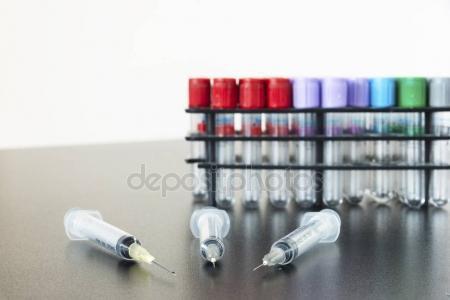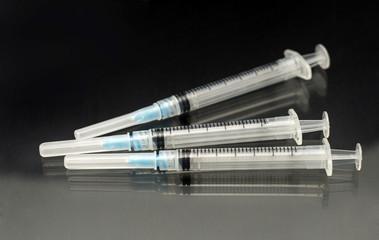The first image is the image on the left, the second image is the image on the right. Analyze the images presented: Is the assertion "An image shows exactly two syringe-related items displayed horizontally." valid? Answer yes or no. No. The first image is the image on the left, the second image is the image on the right. Assess this claim about the two images: "At least one of the images has exactly three syringes.". Correct or not? Answer yes or no. Yes. 